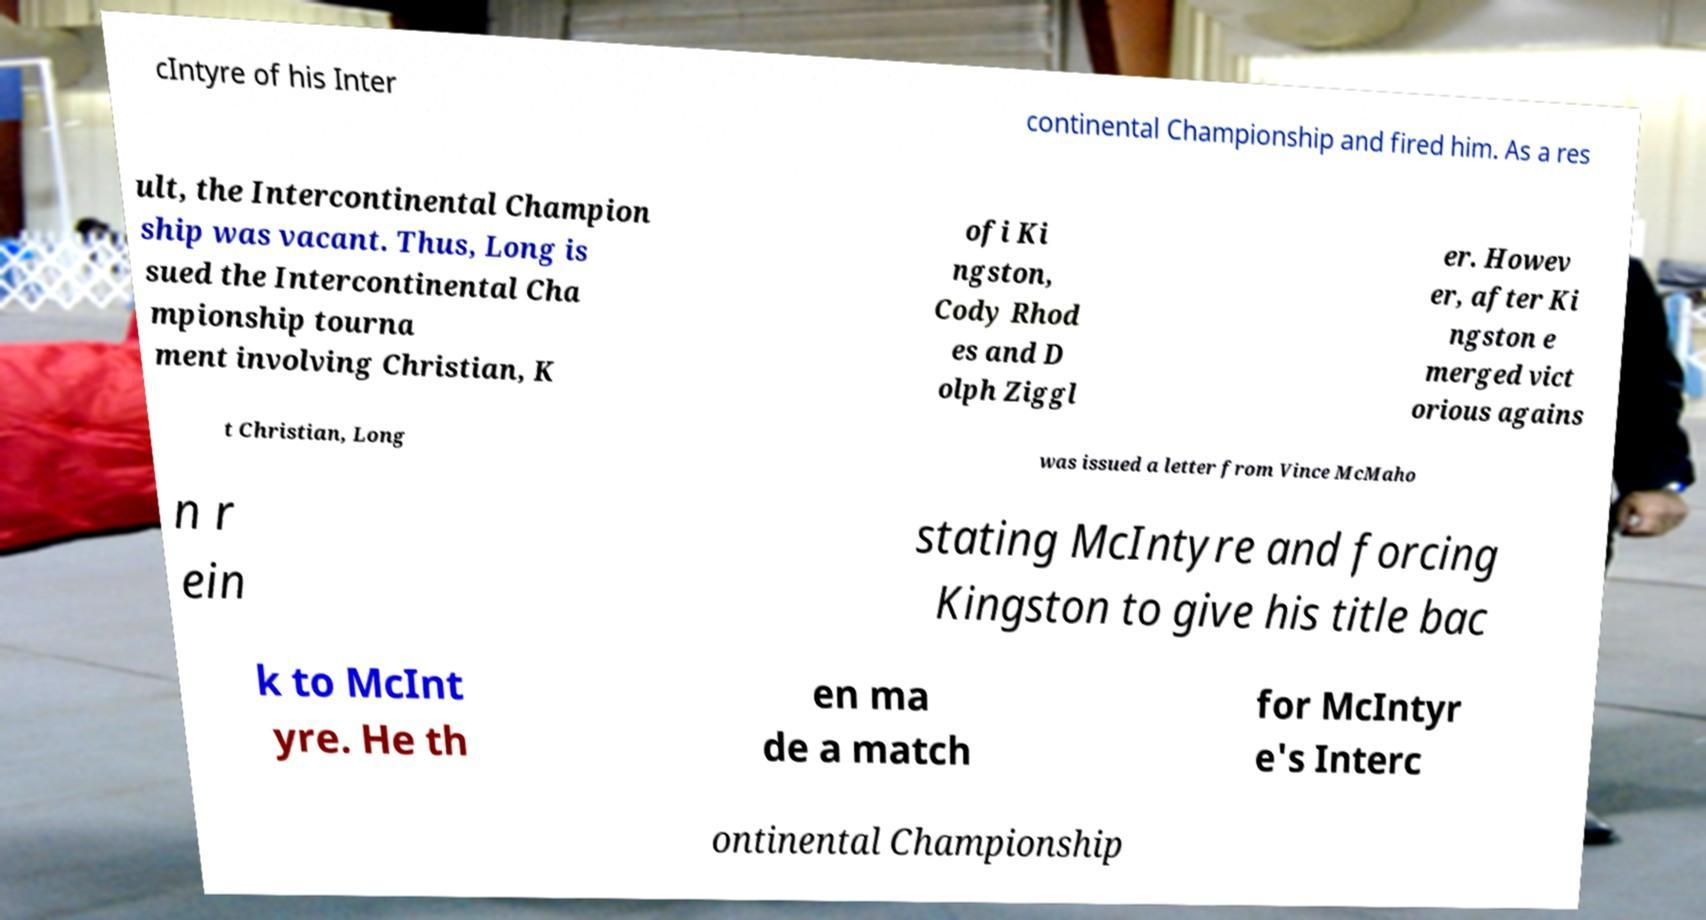Could you assist in decoding the text presented in this image and type it out clearly? cIntyre of his Inter continental Championship and fired him. As a res ult, the Intercontinental Champion ship was vacant. Thus, Long is sued the Intercontinental Cha mpionship tourna ment involving Christian, K ofi Ki ngston, Cody Rhod es and D olph Ziggl er. Howev er, after Ki ngston e merged vict orious agains t Christian, Long was issued a letter from Vince McMaho n r ein stating McIntyre and forcing Kingston to give his title bac k to McInt yre. He th en ma de a match for McIntyr e's Interc ontinental Championship 